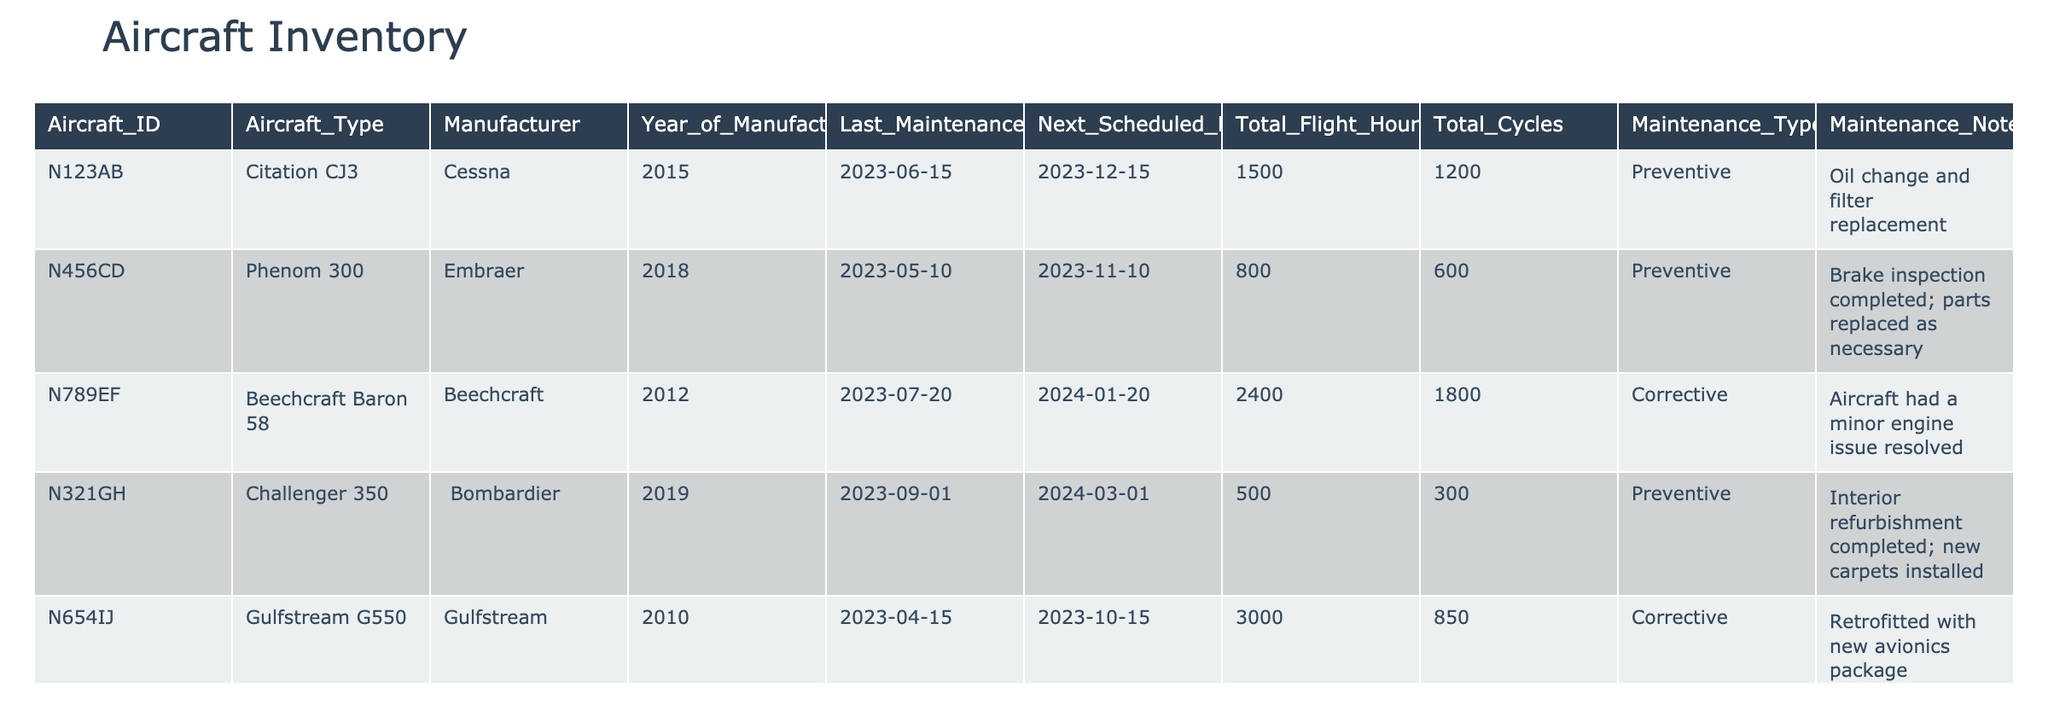What is the Aircraft ID of the Gulfstream G550? The table lists the Gulfstream G550 in the row corresponding to its details. The Aircraft ID associated with this entry is N654IJ.
Answer: N654IJ When is the next scheduled maintenance for the Challenger 350? The Challenger 350 is noted with a next scheduled maintenance date of March 1, 2024, as per the entry in the table.
Answer: 2024-03-01 How many total flight hours does the Beechcraft Baron 58 have? In the table, the total flight hours for the Beechcraft Baron 58 is listed as 2400 hours.
Answer: 2400 What is the difference in total flight hours between the Citation CJ3 and the Phenom 300? The total flight hours for the Citation CJ3 is 1500, and for the Phenom 300, it is 800. The difference is calculated as 1500 - 800 = 700.
Answer: 700 Is there a record of a corrective maintenance type for the Airbus ACJ319? The entry for the Airbus ACJ319 shows the maintenance type listed as "Preventive," which indicates there is no corrective maintenance recorded for this aircraft.
Answer: No Which aircraft had the latest last maintenance date and what is that date? Reviewing the table, the Global 6000 had its last maintenance performed on October 10, 2023, which is later than other entries.
Answer: 2023-10-10 How many aircraft have preventive maintenance listed in the records? The analysis of the table shows the following aircraft with preventive maintenance: Citation CJ3, Phenom 300, Challenger 350, ACJ319, and Hawker 900XP. That totals to 5 aircraft.
Answer: 5 What is the average total cycles across all aircraft listed in the table? To find the average total cycles, sum all the total cycles: 1200 + 600 + 1800 + 300 + 850 + 450 + 500 + 900 = 4850. There are 8 aircraft, so the average is 4850 / 8 = 606.25.
Answer: 606.25 Was there any aircraft noted for interior refurbishment? According to the table, the Challenger 350 had its maintenance noted for completed interior refurbishment along with new carpets installed, which confirms there was such a record.
Answer: Yes 